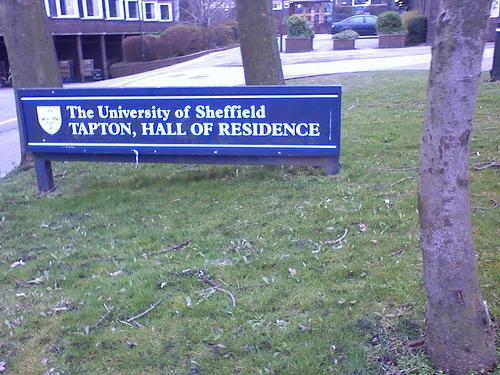Who lives in these buildings? Please explain your reasoning. students. Halls are where the college kids live. 